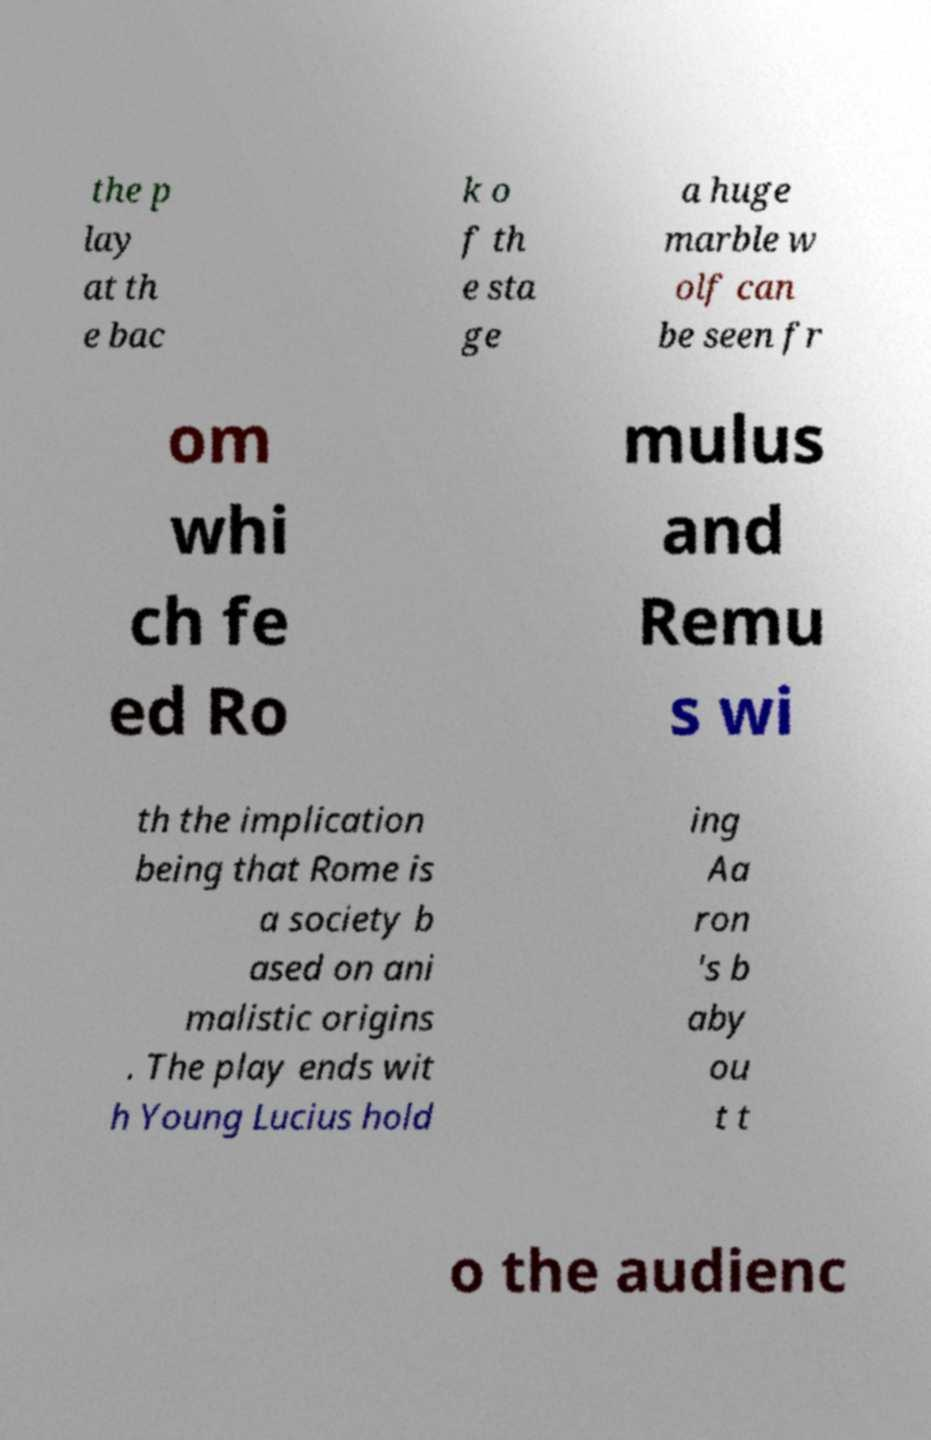I need the written content from this picture converted into text. Can you do that? the p lay at th e bac k o f th e sta ge a huge marble w olf can be seen fr om whi ch fe ed Ro mulus and Remu s wi th the implication being that Rome is a society b ased on ani malistic origins . The play ends wit h Young Lucius hold ing Aa ron 's b aby ou t t o the audienc 